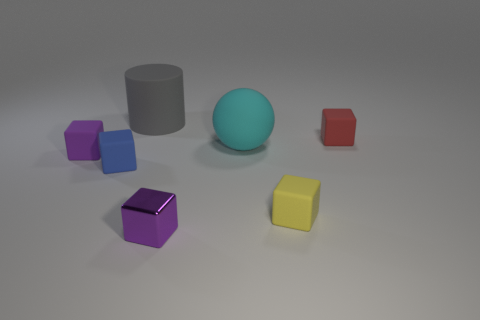There is a matte thing that is both left of the yellow block and right of the big matte cylinder; what is its shape?
Your response must be concise. Sphere. How many objects are either big things that are in front of the large cylinder or small rubber blocks to the left of the big gray thing?
Your response must be concise. 3. What number of other objects are the same size as the gray cylinder?
Your answer should be very brief. 1. There is a large object that is left of the tiny purple metal block; is its color the same as the matte sphere?
Your response must be concise. No. What is the size of the matte object that is to the left of the red cube and to the right of the cyan object?
Provide a succinct answer. Small. How many large things are blue matte things or gray cylinders?
Your answer should be very brief. 1. What is the shape of the big object behind the big cyan ball?
Keep it short and to the point. Cylinder. What number of large green metallic blocks are there?
Keep it short and to the point. 0. Is the material of the large cyan thing the same as the small yellow thing?
Keep it short and to the point. Yes. Are there more cyan matte balls that are to the left of the big cylinder than tiny yellow spheres?
Provide a succinct answer. No. 